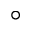<formula> <loc_0><loc_0><loc_500><loc_500>^ { \circ }</formula> 